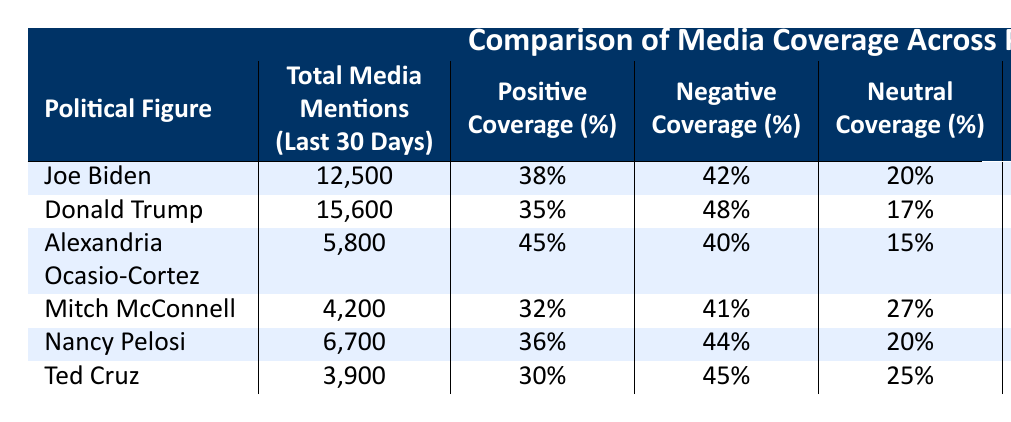What is the total number of media mentions for Donald Trump in the last 30 days? The table shows that Donald Trump has a total of 15,600 media mentions in the last 30 days. I can simply find this information by looking directly at the corresponding row in the table.
Answer: 15,600 Which political figure received the highest percentage of positive coverage? By inspecting the "Positive Coverage (%)" column, Alexandria Ocasio-Cortez has the highest percentage at 45%. I compared this percentage with those of the other political figures to find the highest.
Answer: Alexandria Ocasio-Cortez What is the average total media mentions for all political figures listed in the table? To find the average, I first sum the total media mentions of all figures: (12,500 + 15,600 + 5,800 + 4,200 + 6,700 + 3,900) = 48,700. This gives us a total of 6 figures, so the average is 48,700 / 6 = 8,116.67, which rounds to 8,117.
Answer: 8,117 Is it true that Joe Biden had more press conference appearances than Donald Trump? Joe Biden has 6 press conference appearances while Donald Trump has 2. Therefore, it is true that Joe Biden had more appearances. I compared the entries in the "Press Conference Appearances" column.
Answer: Yes What is the difference in social media engagement between Joe Biden and Ted Cruz? Joe Biden has 2,800,000 in social media engagement while Ted Cruz has 1,100,000. I calculated the difference by subtracting Ted Cruz's engagement from Joe Biden's: 2,800,000 - 1,100,000 = 1,700,000.
Answer: 1,700,000 Which political figure has the highest negative coverage percentage? From the "Negative Coverage (%)" column, Donald Trump has the highest percentage at 48%. I looked through each figure's negative coverage and found Trump had the highest value.
Answer: Donald Trump How many media mentions do Alexandria Ocasio-Cortez and Nancy Pelosi have combined? Alexandria Ocasio-Cortez has 5,800 mentions and Nancy Pelosi has 6,700. Adding these together gives 5,800 + 6,700 = 12,500.
Answer: 12,500 Does Mitch McConnell have more neutral coverage percentage than Nancy Pelosi? Mitch McConnell has 27% neutral coverage while Nancy Pelosi has 20%. A simple comparison shows that 27% is greater than 20%.
Answer: Yes 